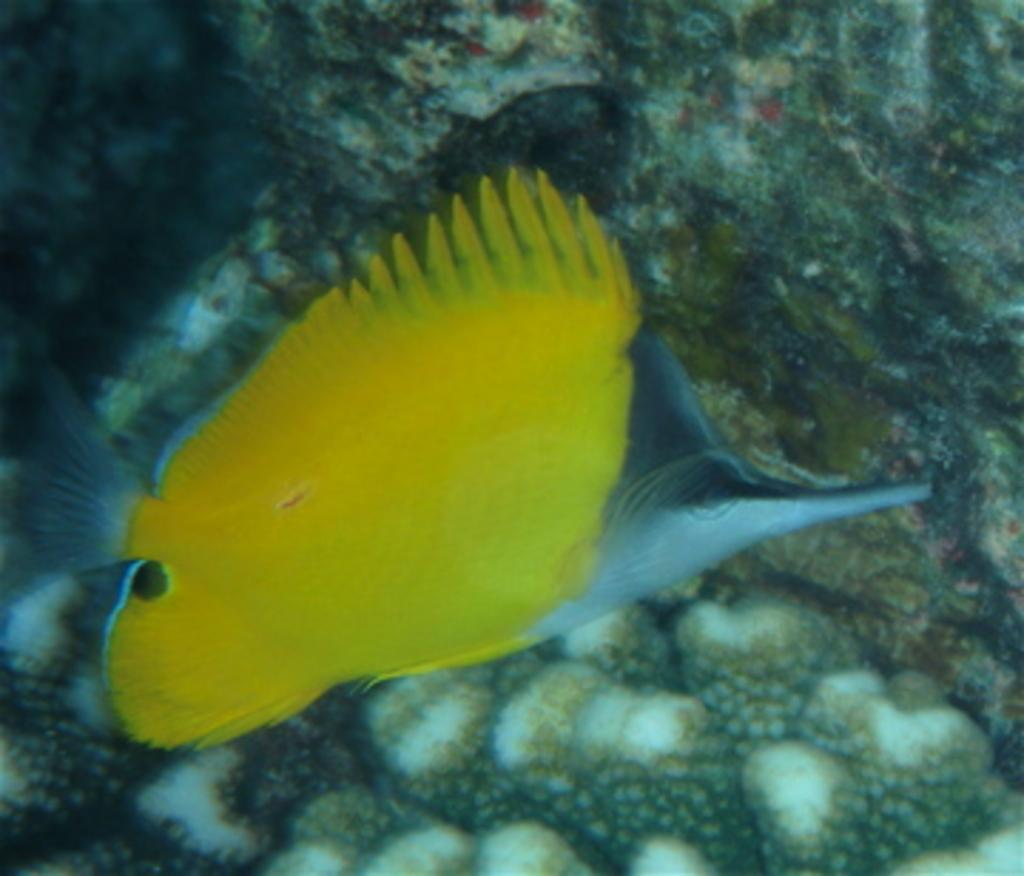What type of animal is in the image? There is a fish in the image. What colors can be seen on the fish? The fish has yellow and ash colors. What can be seen in the background of the image? There is a different background visible in the image. Where is the aunt sitting in the image? There is no aunt present in the image; it only features a fish with a different background. 